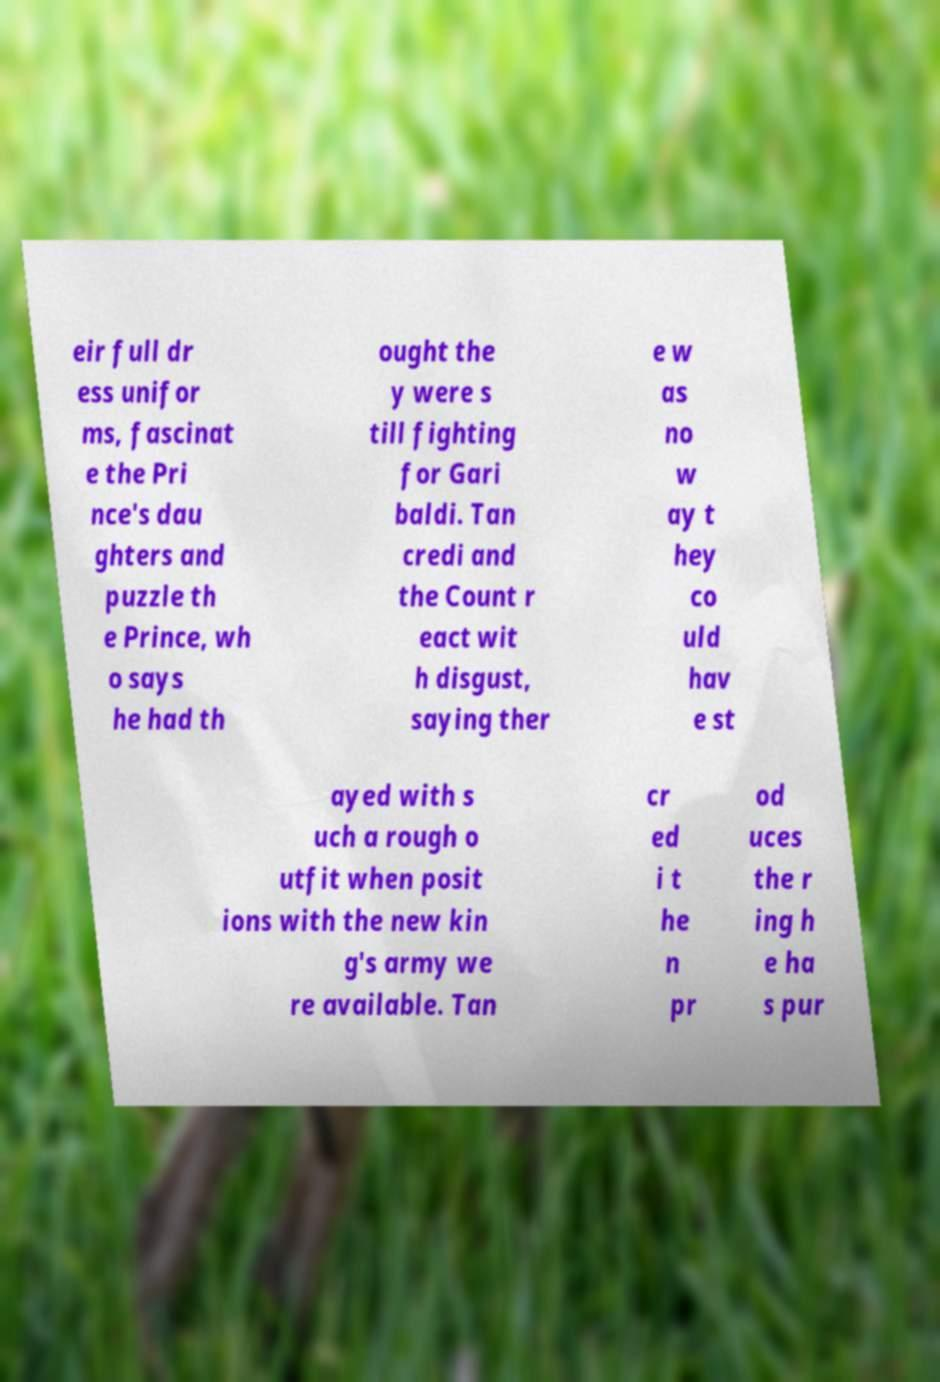Can you accurately transcribe the text from the provided image for me? eir full dr ess unifor ms, fascinat e the Pri nce's dau ghters and puzzle th e Prince, wh o says he had th ought the y were s till fighting for Gari baldi. Tan credi and the Count r eact wit h disgust, saying ther e w as no w ay t hey co uld hav e st ayed with s uch a rough o utfit when posit ions with the new kin g's army we re available. Tan cr ed i t he n pr od uces the r ing h e ha s pur 